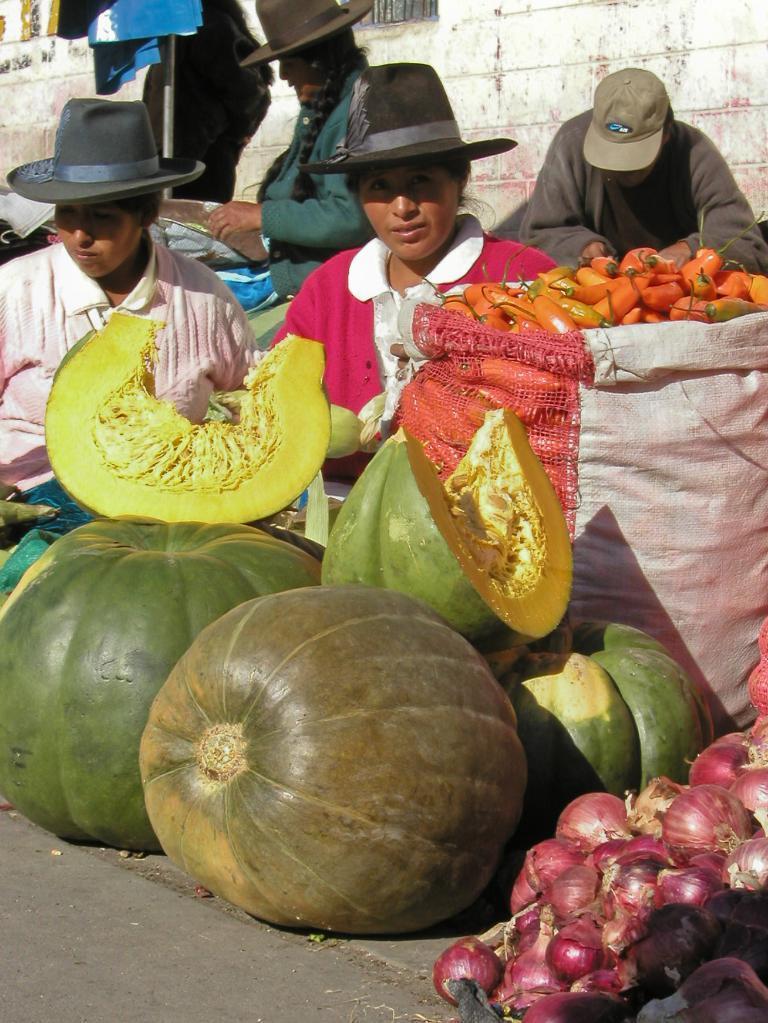Describe this image in one or two sentences. This picture describes about group of people, they wore caps, in front of them we can find few vegetables. 